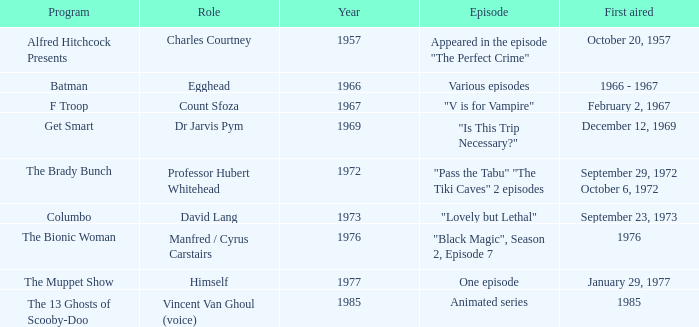What episode was first aired in 1976? "Black Magic", Season 2, Episode 7. 